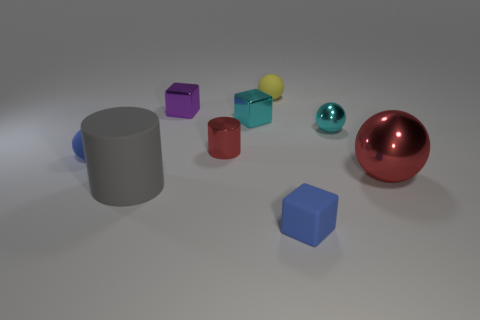Is there anything else that has the same color as the big cylinder? Actually, in the image provided, there is no other object with the exact same color as the large gray cylinder. Each object has its own unique hue. 